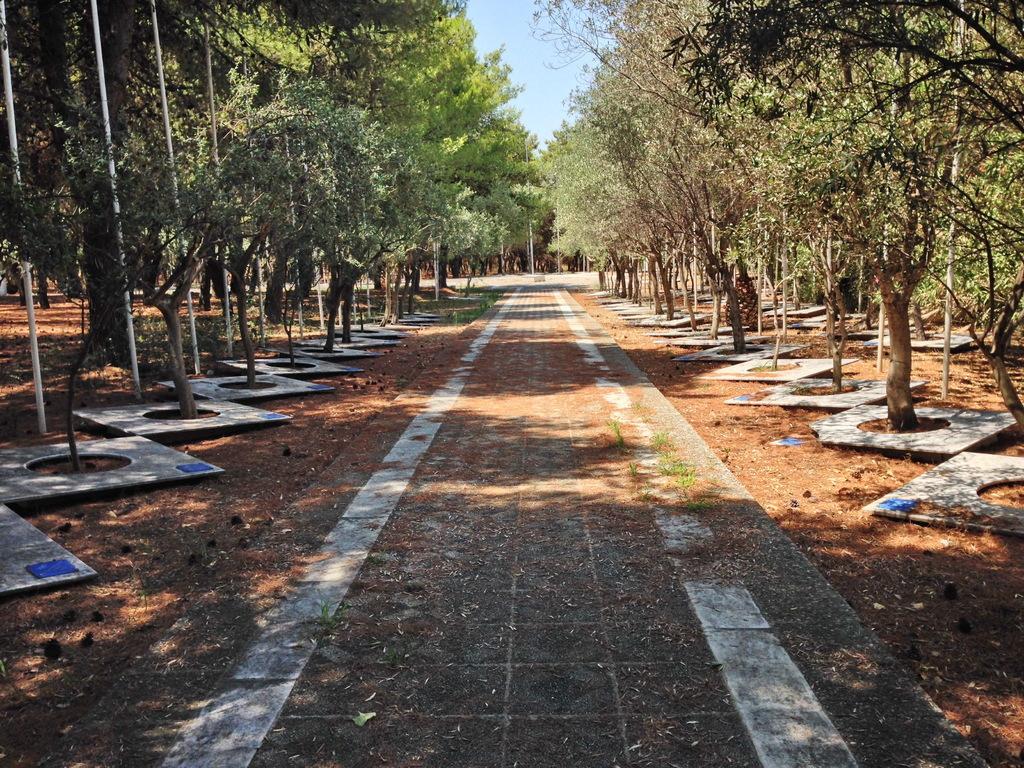Could you give a brief overview of what you see in this image? In this image we can see trees, poles, also we can see the sky. 